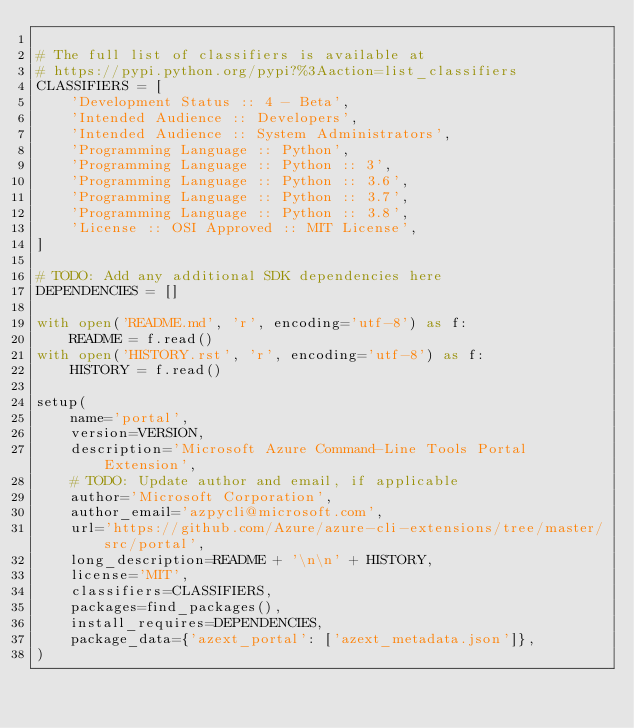<code> <loc_0><loc_0><loc_500><loc_500><_Python_>
# The full list of classifiers is available at
# https://pypi.python.org/pypi?%3Aaction=list_classifiers
CLASSIFIERS = [
    'Development Status :: 4 - Beta',
    'Intended Audience :: Developers',
    'Intended Audience :: System Administrators',
    'Programming Language :: Python',
    'Programming Language :: Python :: 3',
    'Programming Language :: Python :: 3.6',
    'Programming Language :: Python :: 3.7',
    'Programming Language :: Python :: 3.8',
    'License :: OSI Approved :: MIT License',
]

# TODO: Add any additional SDK dependencies here
DEPENDENCIES = []

with open('README.md', 'r', encoding='utf-8') as f:
    README = f.read()
with open('HISTORY.rst', 'r', encoding='utf-8') as f:
    HISTORY = f.read()

setup(
    name='portal',
    version=VERSION,
    description='Microsoft Azure Command-Line Tools Portal Extension',
    # TODO: Update author and email, if applicable
    author='Microsoft Corporation',
    author_email='azpycli@microsoft.com',
    url='https://github.com/Azure/azure-cli-extensions/tree/master/src/portal',
    long_description=README + '\n\n' + HISTORY,
    license='MIT',
    classifiers=CLASSIFIERS,
    packages=find_packages(),
    install_requires=DEPENDENCIES,
    package_data={'azext_portal': ['azext_metadata.json']},
)
</code> 